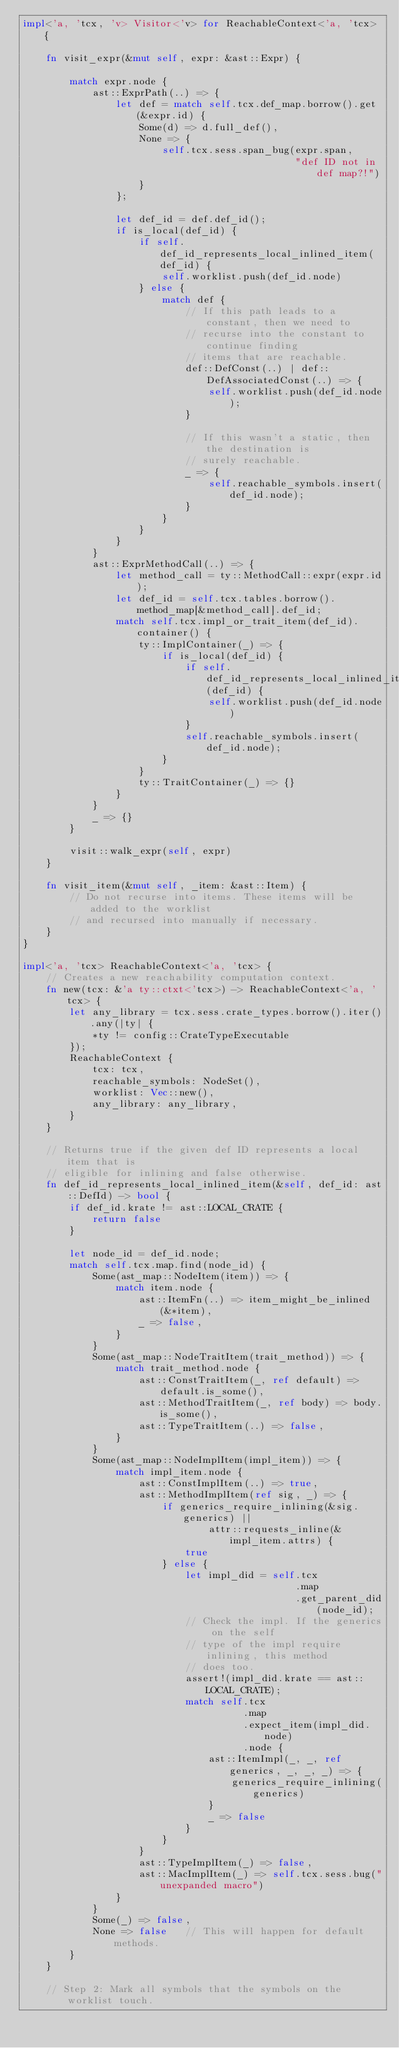<code> <loc_0><loc_0><loc_500><loc_500><_Rust_>impl<'a, 'tcx, 'v> Visitor<'v> for ReachableContext<'a, 'tcx> {

    fn visit_expr(&mut self, expr: &ast::Expr) {

        match expr.node {
            ast::ExprPath(..) => {
                let def = match self.tcx.def_map.borrow().get(&expr.id) {
                    Some(d) => d.full_def(),
                    None => {
                        self.tcx.sess.span_bug(expr.span,
                                               "def ID not in def map?!")
                    }
                };

                let def_id = def.def_id();
                if is_local(def_id) {
                    if self.def_id_represents_local_inlined_item(def_id) {
                        self.worklist.push(def_id.node)
                    } else {
                        match def {
                            // If this path leads to a constant, then we need to
                            // recurse into the constant to continue finding
                            // items that are reachable.
                            def::DefConst(..) | def::DefAssociatedConst(..) => {
                                self.worklist.push(def_id.node);
                            }

                            // If this wasn't a static, then the destination is
                            // surely reachable.
                            _ => {
                                self.reachable_symbols.insert(def_id.node);
                            }
                        }
                    }
                }
            }
            ast::ExprMethodCall(..) => {
                let method_call = ty::MethodCall::expr(expr.id);
                let def_id = self.tcx.tables.borrow().method_map[&method_call].def_id;
                match self.tcx.impl_or_trait_item(def_id).container() {
                    ty::ImplContainer(_) => {
                        if is_local(def_id) {
                            if self.def_id_represents_local_inlined_item(def_id) {
                                self.worklist.push(def_id.node)
                            }
                            self.reachable_symbols.insert(def_id.node);
                        }
                    }
                    ty::TraitContainer(_) => {}
                }
            }
            _ => {}
        }

        visit::walk_expr(self, expr)
    }

    fn visit_item(&mut self, _item: &ast::Item) {
        // Do not recurse into items. These items will be added to the worklist
        // and recursed into manually if necessary.
    }
}

impl<'a, 'tcx> ReachableContext<'a, 'tcx> {
    // Creates a new reachability computation context.
    fn new(tcx: &'a ty::ctxt<'tcx>) -> ReachableContext<'a, 'tcx> {
        let any_library = tcx.sess.crate_types.borrow().iter().any(|ty| {
            *ty != config::CrateTypeExecutable
        });
        ReachableContext {
            tcx: tcx,
            reachable_symbols: NodeSet(),
            worklist: Vec::new(),
            any_library: any_library,
        }
    }

    // Returns true if the given def ID represents a local item that is
    // eligible for inlining and false otherwise.
    fn def_id_represents_local_inlined_item(&self, def_id: ast::DefId) -> bool {
        if def_id.krate != ast::LOCAL_CRATE {
            return false
        }

        let node_id = def_id.node;
        match self.tcx.map.find(node_id) {
            Some(ast_map::NodeItem(item)) => {
                match item.node {
                    ast::ItemFn(..) => item_might_be_inlined(&*item),
                    _ => false,
                }
            }
            Some(ast_map::NodeTraitItem(trait_method)) => {
                match trait_method.node {
                    ast::ConstTraitItem(_, ref default) => default.is_some(),
                    ast::MethodTraitItem(_, ref body) => body.is_some(),
                    ast::TypeTraitItem(..) => false,
                }
            }
            Some(ast_map::NodeImplItem(impl_item)) => {
                match impl_item.node {
                    ast::ConstImplItem(..) => true,
                    ast::MethodImplItem(ref sig, _) => {
                        if generics_require_inlining(&sig.generics) ||
                                attr::requests_inline(&impl_item.attrs) {
                            true
                        } else {
                            let impl_did = self.tcx
                                               .map
                                               .get_parent_did(node_id);
                            // Check the impl. If the generics on the self
                            // type of the impl require inlining, this method
                            // does too.
                            assert!(impl_did.krate == ast::LOCAL_CRATE);
                            match self.tcx
                                      .map
                                      .expect_item(impl_did.node)
                                      .node {
                                ast::ItemImpl(_, _, ref generics, _, _, _) => {
                                    generics_require_inlining(generics)
                                }
                                _ => false
                            }
                        }
                    }
                    ast::TypeImplItem(_) => false,
                    ast::MacImplItem(_) => self.tcx.sess.bug("unexpanded macro")
                }
            }
            Some(_) => false,
            None => false   // This will happen for default methods.
        }
    }

    // Step 2: Mark all symbols that the symbols on the worklist touch.</code> 